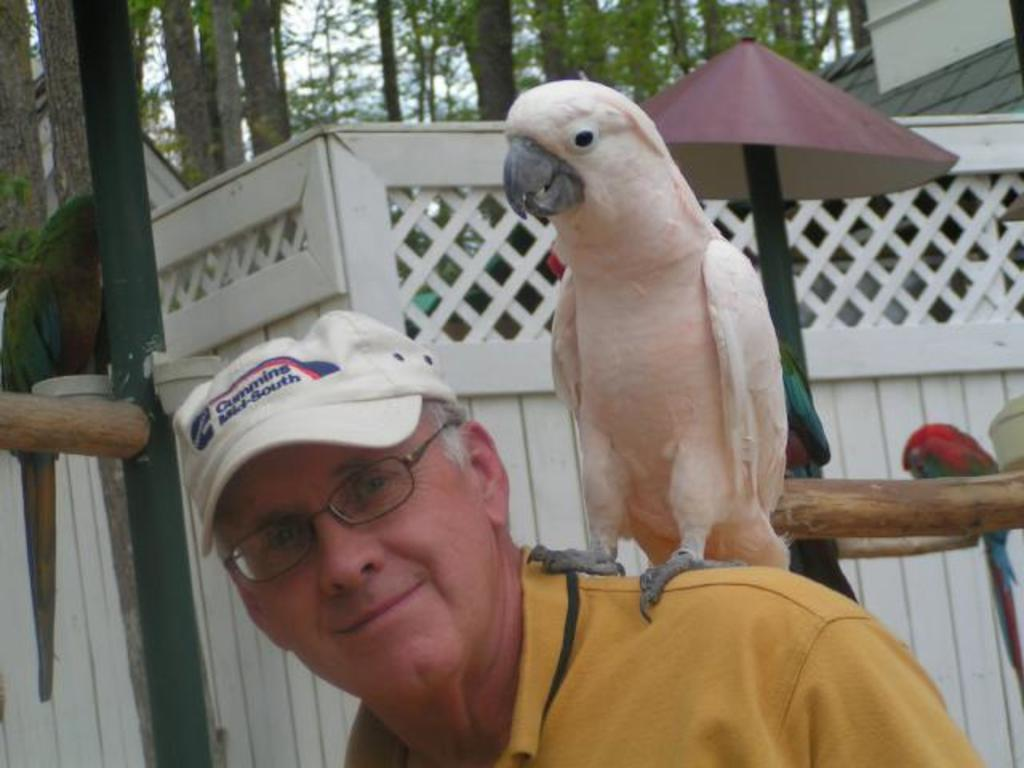What type of animal is on the man's shoulder in the image? There is a parrot on a man's shoulder in the image. What is the man wearing on his head? The man is wearing a cap on his head. What is the man wearing on his face? The man is wearing spectacles on his face. What type of structure is visible in the image? There is a building visible in the image. How many parrots are present in the image? There are parrots in the image, but the exact number is not specified. What type of vegetation is visible in the image? There are trees in the image. What type of noise is the fireman making in the image? There is no fireman present in the image, and therefore no such noise can be heard. Can you tell me how many kittens are sitting on the parrot's head in the image? There are no kittens present in the image, and therefore none are sitting on the parrot's head. 